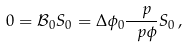<formula> <loc_0><loc_0><loc_500><loc_500>0 = \mathcal { B } _ { 0 } S _ { 0 } = \Delta \phi _ { 0 } \frac { \ p } { \ p \phi } S _ { 0 } \, ,</formula> 